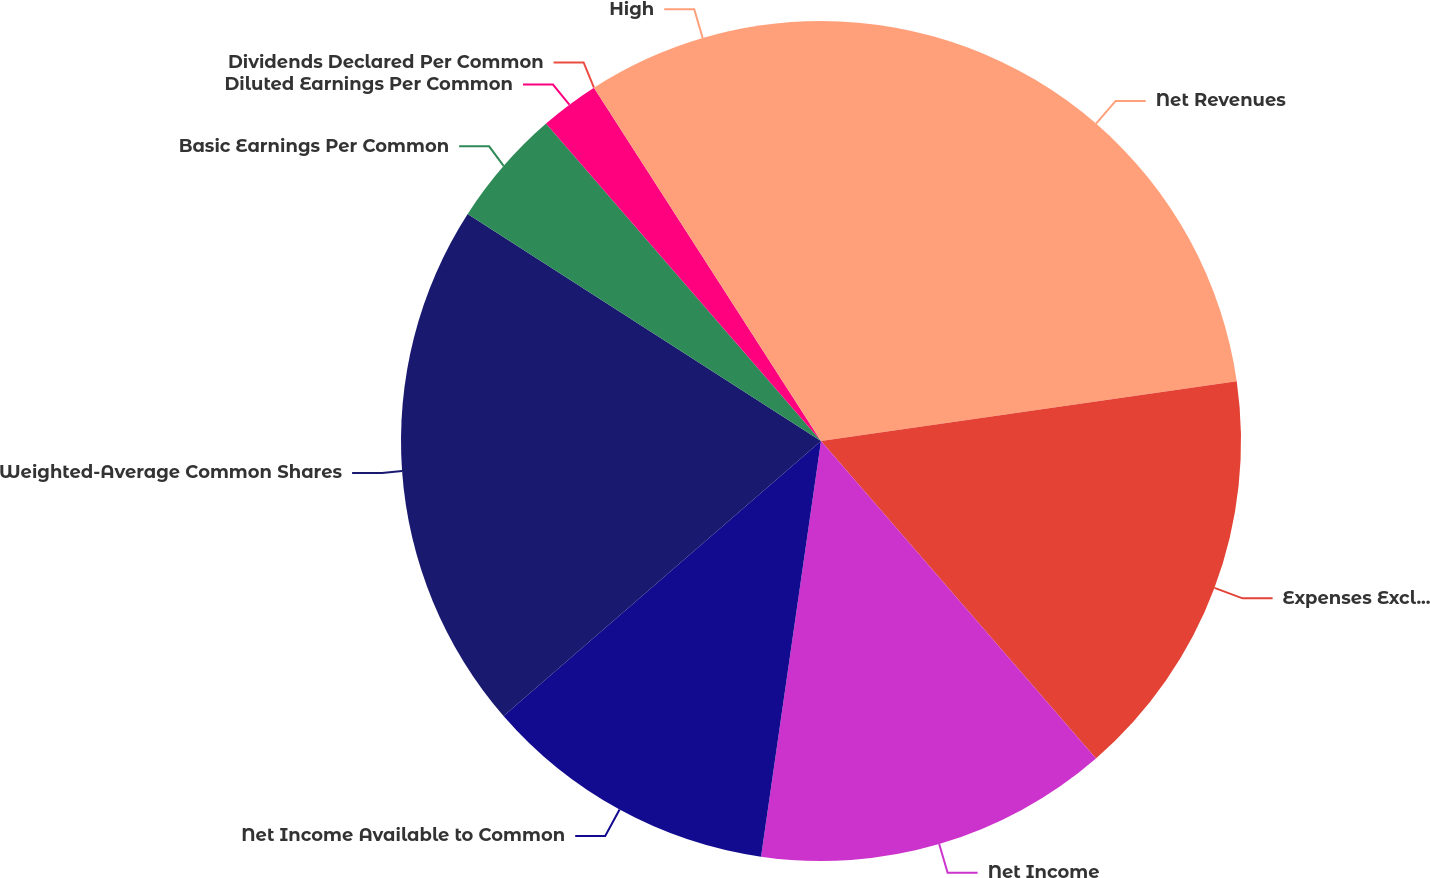<chart> <loc_0><loc_0><loc_500><loc_500><pie_chart><fcel>Net Revenues<fcel>Expenses Excluding Interest<fcel>Net Income<fcel>Net Income Available to Common<fcel>Weighted-Average Common Shares<fcel>Basic Earnings Per Common<fcel>Diluted Earnings Per Common<fcel>Dividends Declared Per Common<fcel>High<nl><fcel>22.73%<fcel>15.91%<fcel>13.64%<fcel>11.36%<fcel>20.45%<fcel>4.55%<fcel>2.27%<fcel>0.0%<fcel>9.09%<nl></chart> 